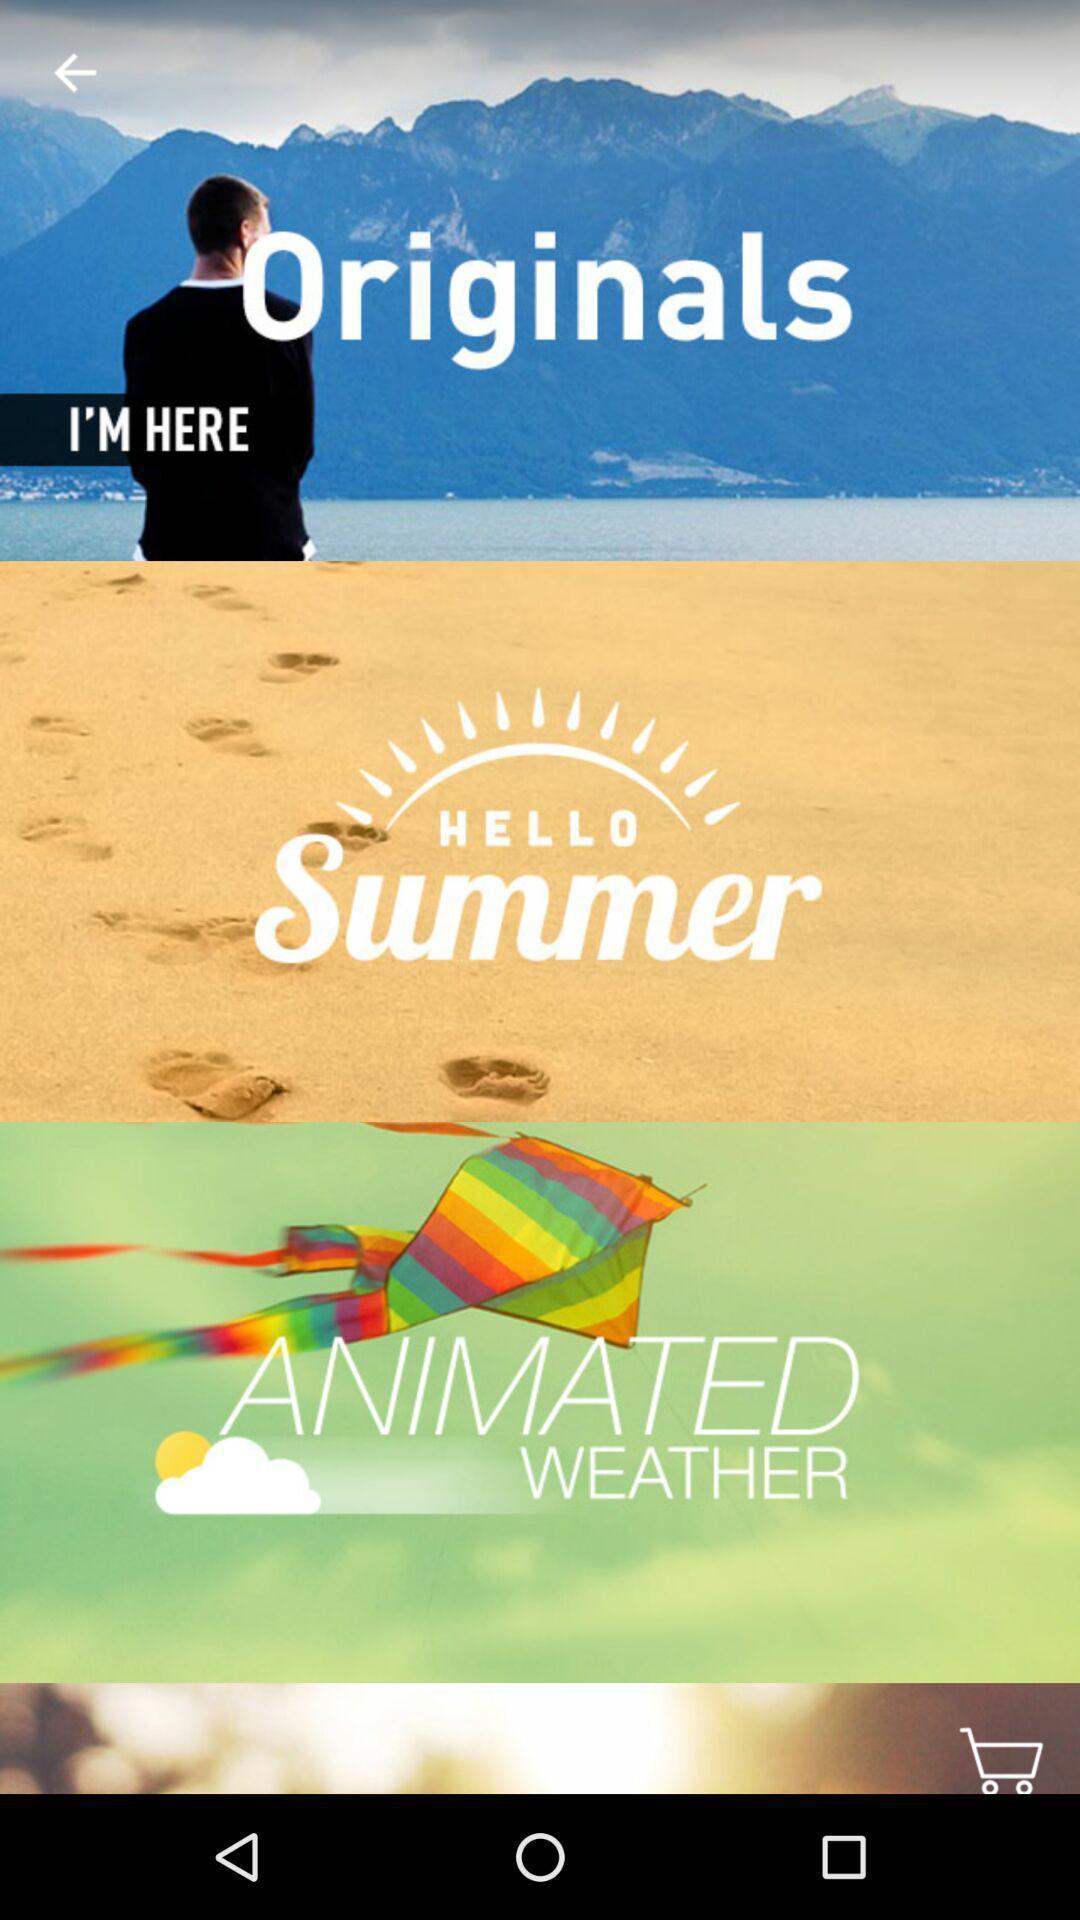Explain the elements present in this screenshot. Screen shows multiple options in shopping application. 